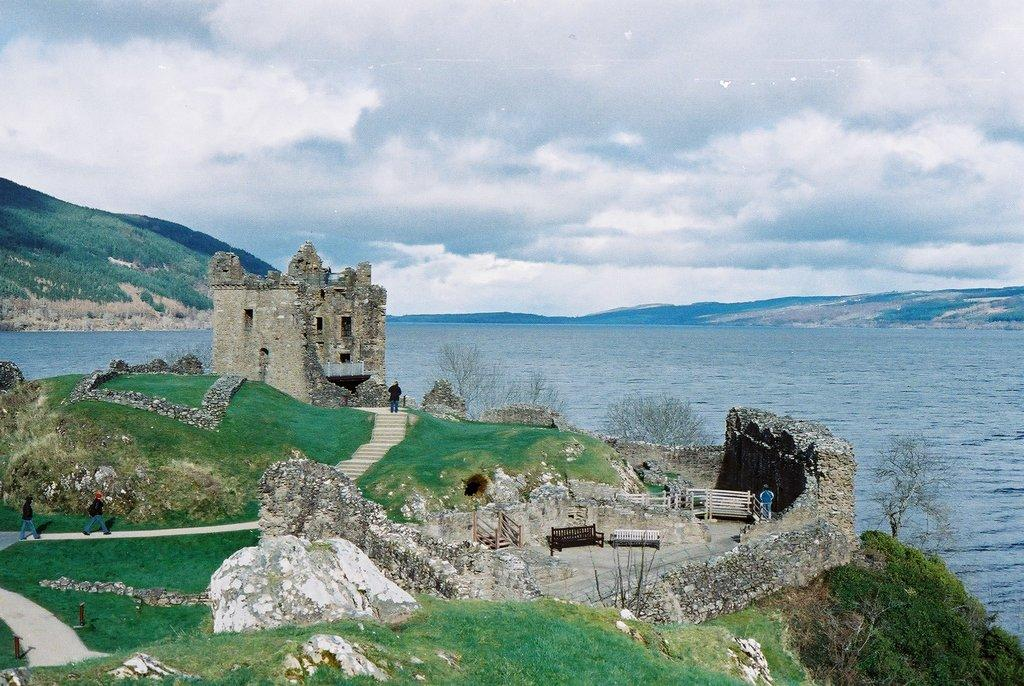What type of structure is in the image? There is an ancient building in the image. What can be used for sitting in the image? There are benches in the image. What type of natural elements are present in the image? Rocks, trees, and plants are present in the image. Are there any living beings in the image? Yes, there are people in the image. What geographical feature is shown in the image? The image shows a hill. What can be seen flowing in the image? Water is visible in the image. What is visible in the background of the image? There are hills and the sky in the background of the image. What type of pain is the person experiencing in the image? There is no indication of pain or any emotional state in the image; it only shows people, an ancient building, and other elements. 